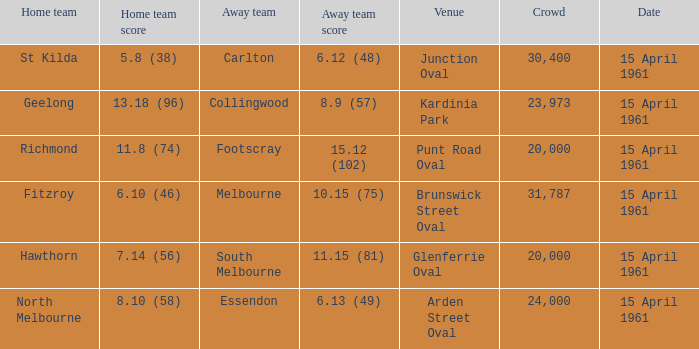What was the score for the home team St Kilda? 5.8 (38). 